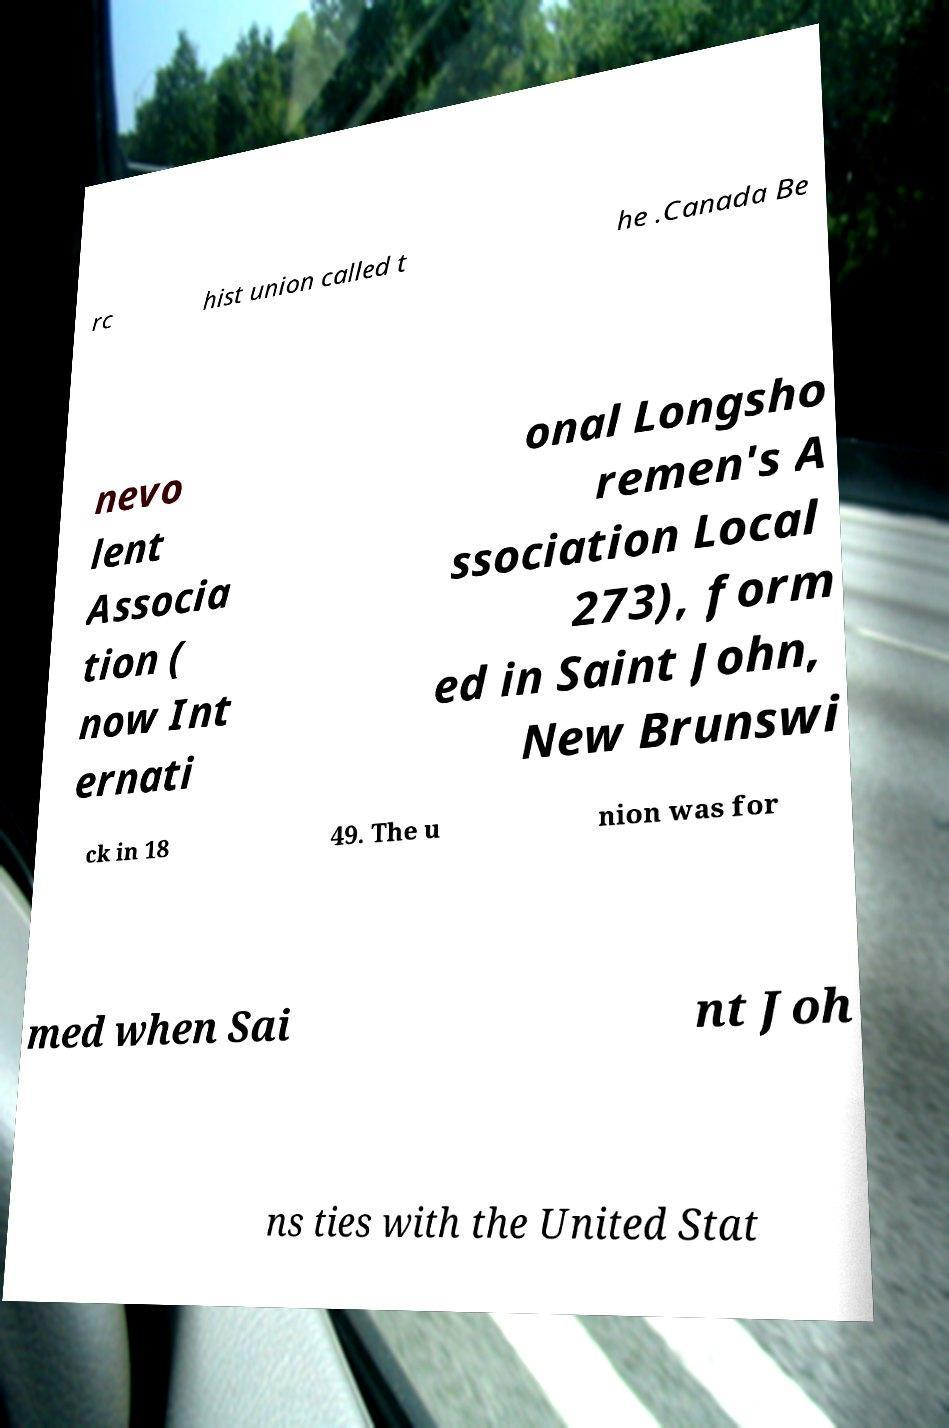Could you extract and type out the text from this image? rc hist union called t he .Canada Be nevo lent Associa tion ( now Int ernati onal Longsho remen's A ssociation Local 273), form ed in Saint John, New Brunswi ck in 18 49. The u nion was for med when Sai nt Joh ns ties with the United Stat 